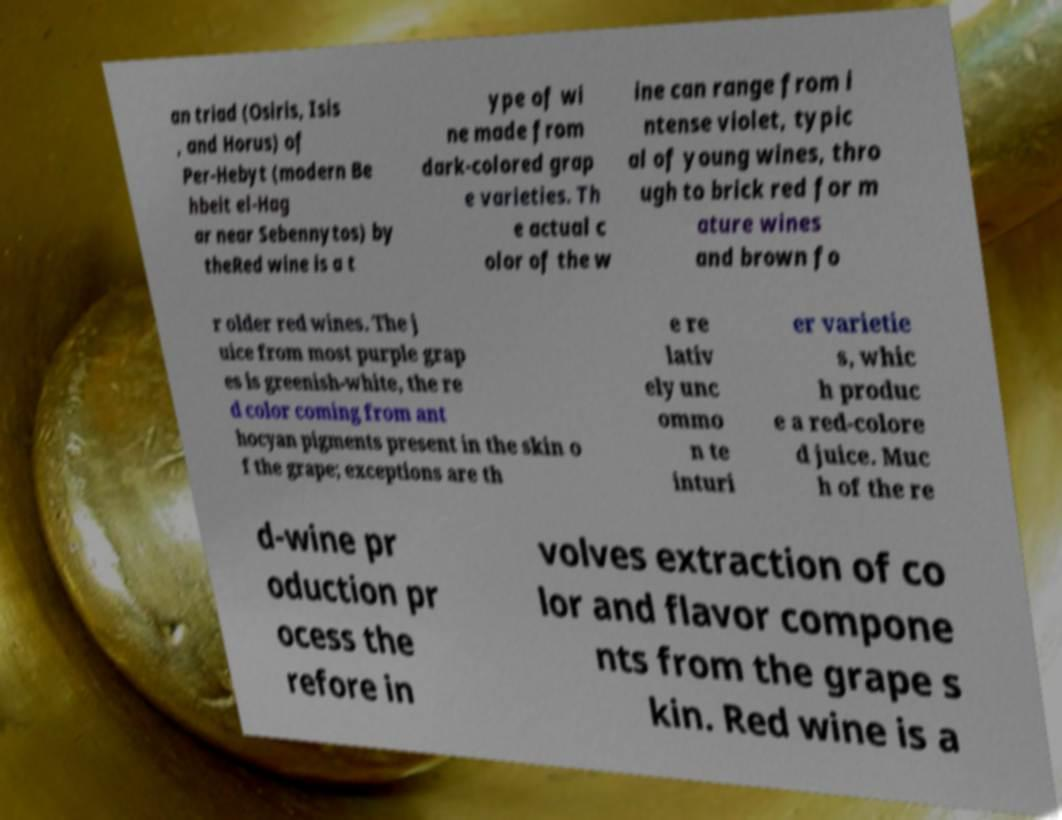Could you assist in decoding the text presented in this image and type it out clearly? an triad (Osiris, Isis , and Horus) of Per-Hebyt (modern Be hbeit el-Hag ar near Sebennytos) by theRed wine is a t ype of wi ne made from dark-colored grap e varieties. Th e actual c olor of the w ine can range from i ntense violet, typic al of young wines, thro ugh to brick red for m ature wines and brown fo r older red wines. The j uice from most purple grap es is greenish-white, the re d color coming from ant hocyan pigments present in the skin o f the grape; exceptions are th e re lativ ely unc ommo n te inturi er varietie s, whic h produc e a red-colore d juice. Muc h of the re d-wine pr oduction pr ocess the refore in volves extraction of co lor and flavor compone nts from the grape s kin. Red wine is a 